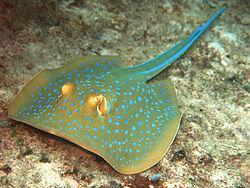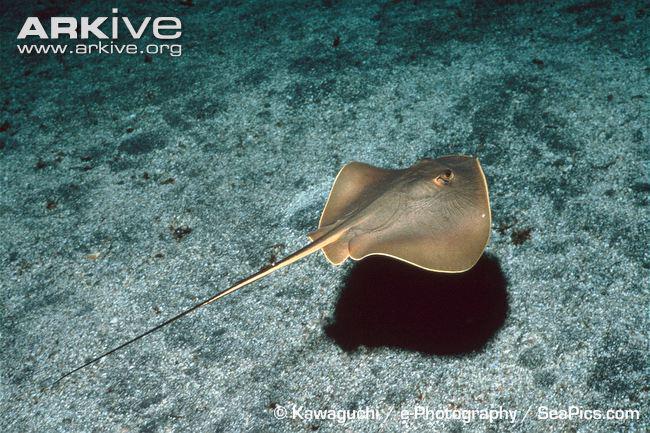The first image is the image on the left, the second image is the image on the right. Assess this claim about the two images: "An image features exactly one stingray, which has sky-blue dots.". Correct or not? Answer yes or no. Yes. The first image is the image on the left, the second image is the image on the right. Assess this claim about the two images: "One of the rays is green and yellow with blue specks.". Correct or not? Answer yes or no. Yes. 